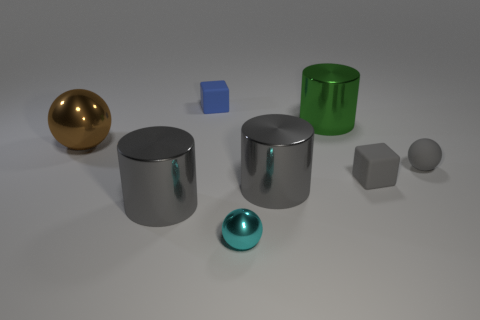Subtract all green metal cylinders. How many cylinders are left? 2 Add 1 cyan rubber objects. How many objects exist? 9 Subtract 2 balls. How many balls are left? 1 Subtract all green cylinders. How many cylinders are left? 2 Subtract all red balls. How many gray cylinders are left? 2 Add 3 gray cubes. How many gray cubes are left? 4 Add 3 rubber blocks. How many rubber blocks exist? 5 Subtract 0 red balls. How many objects are left? 8 Subtract all cylinders. How many objects are left? 5 Subtract all red balls. Subtract all cyan cylinders. How many balls are left? 3 